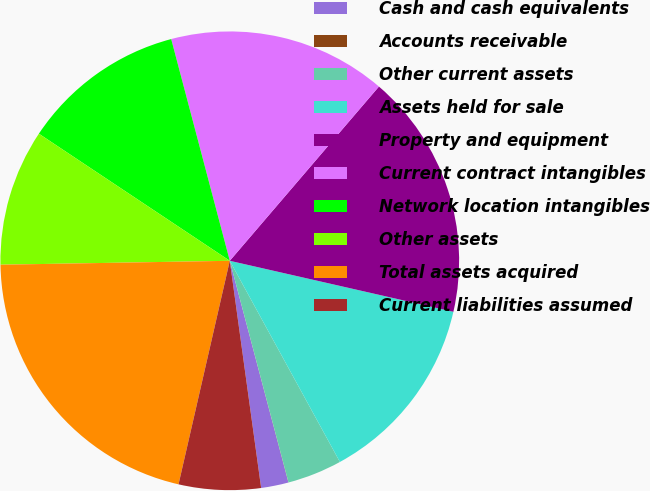<chart> <loc_0><loc_0><loc_500><loc_500><pie_chart><fcel>Cash and cash equivalents<fcel>Accounts receivable<fcel>Other current assets<fcel>Assets held for sale<fcel>Property and equipment<fcel>Current contract intangibles<fcel>Network location intangibles<fcel>Other assets<fcel>Total assets acquired<fcel>Current liabilities assumed<nl><fcel>1.93%<fcel>0.01%<fcel>3.85%<fcel>13.46%<fcel>17.3%<fcel>15.38%<fcel>11.54%<fcel>9.62%<fcel>21.14%<fcel>5.77%<nl></chart> 